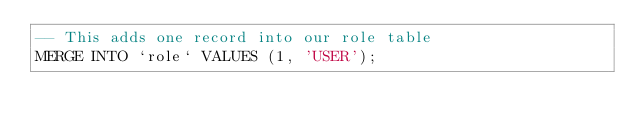Convert code to text. <code><loc_0><loc_0><loc_500><loc_500><_SQL_>-- This adds one record into our role table
MERGE INTO `role` VALUES (1, 'USER');</code> 